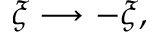<formula> <loc_0><loc_0><loc_500><loc_500>\xi \longrightarrow - \xi ,</formula> 